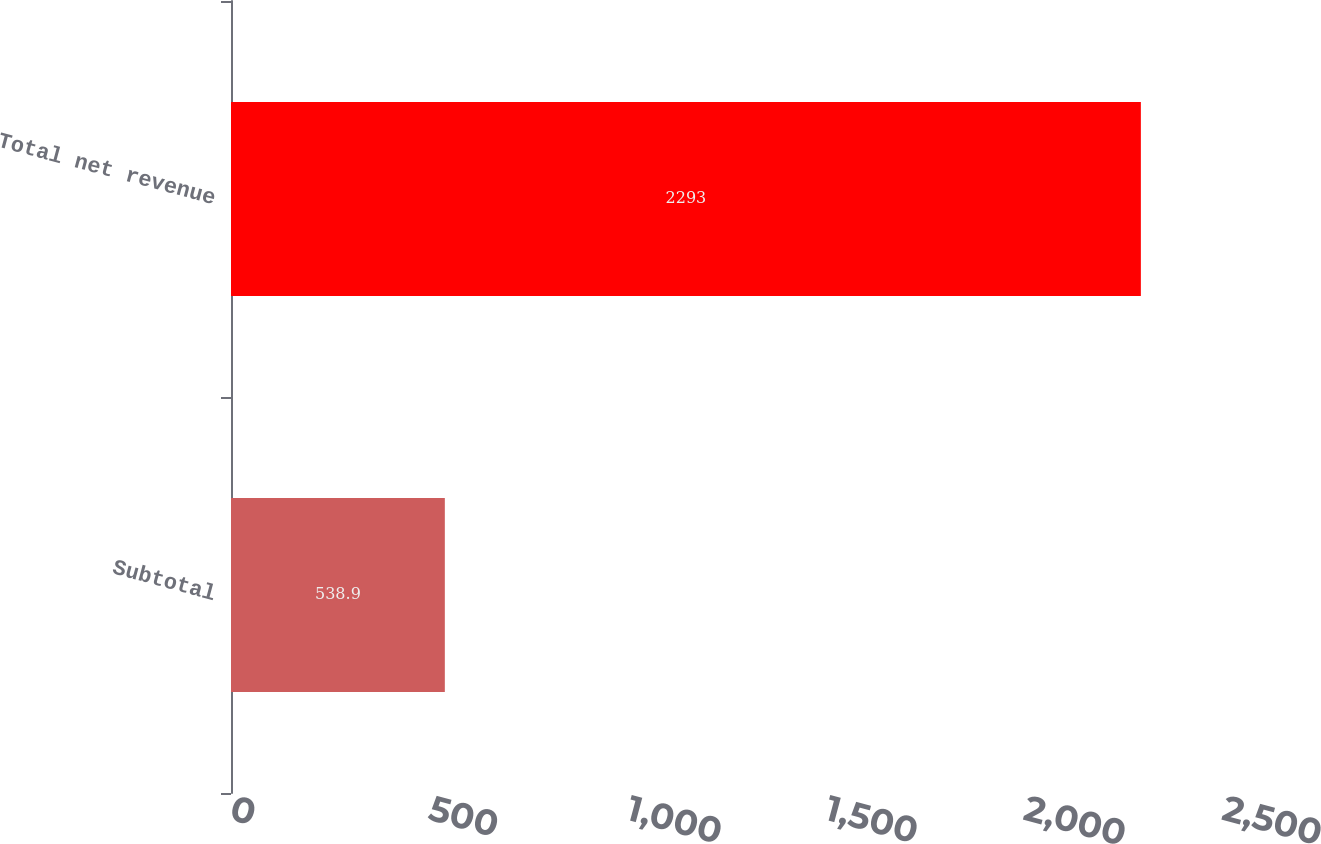Convert chart to OTSL. <chart><loc_0><loc_0><loc_500><loc_500><bar_chart><fcel>Subtotal<fcel>Total net revenue<nl><fcel>538.9<fcel>2293<nl></chart> 